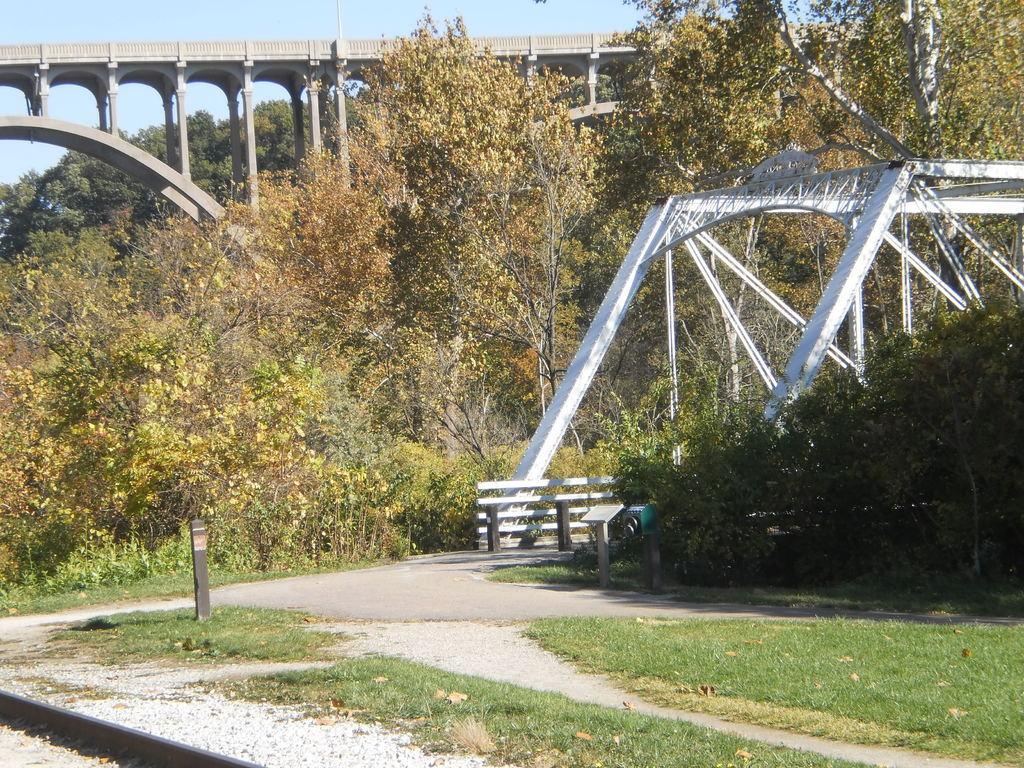How would you summarize this image in a sentence or two? In this image there is grass on the ground. Beside it there is a road. There is a railing beside the road. In the background there are trees and a bridge. At the top there is the sky. 